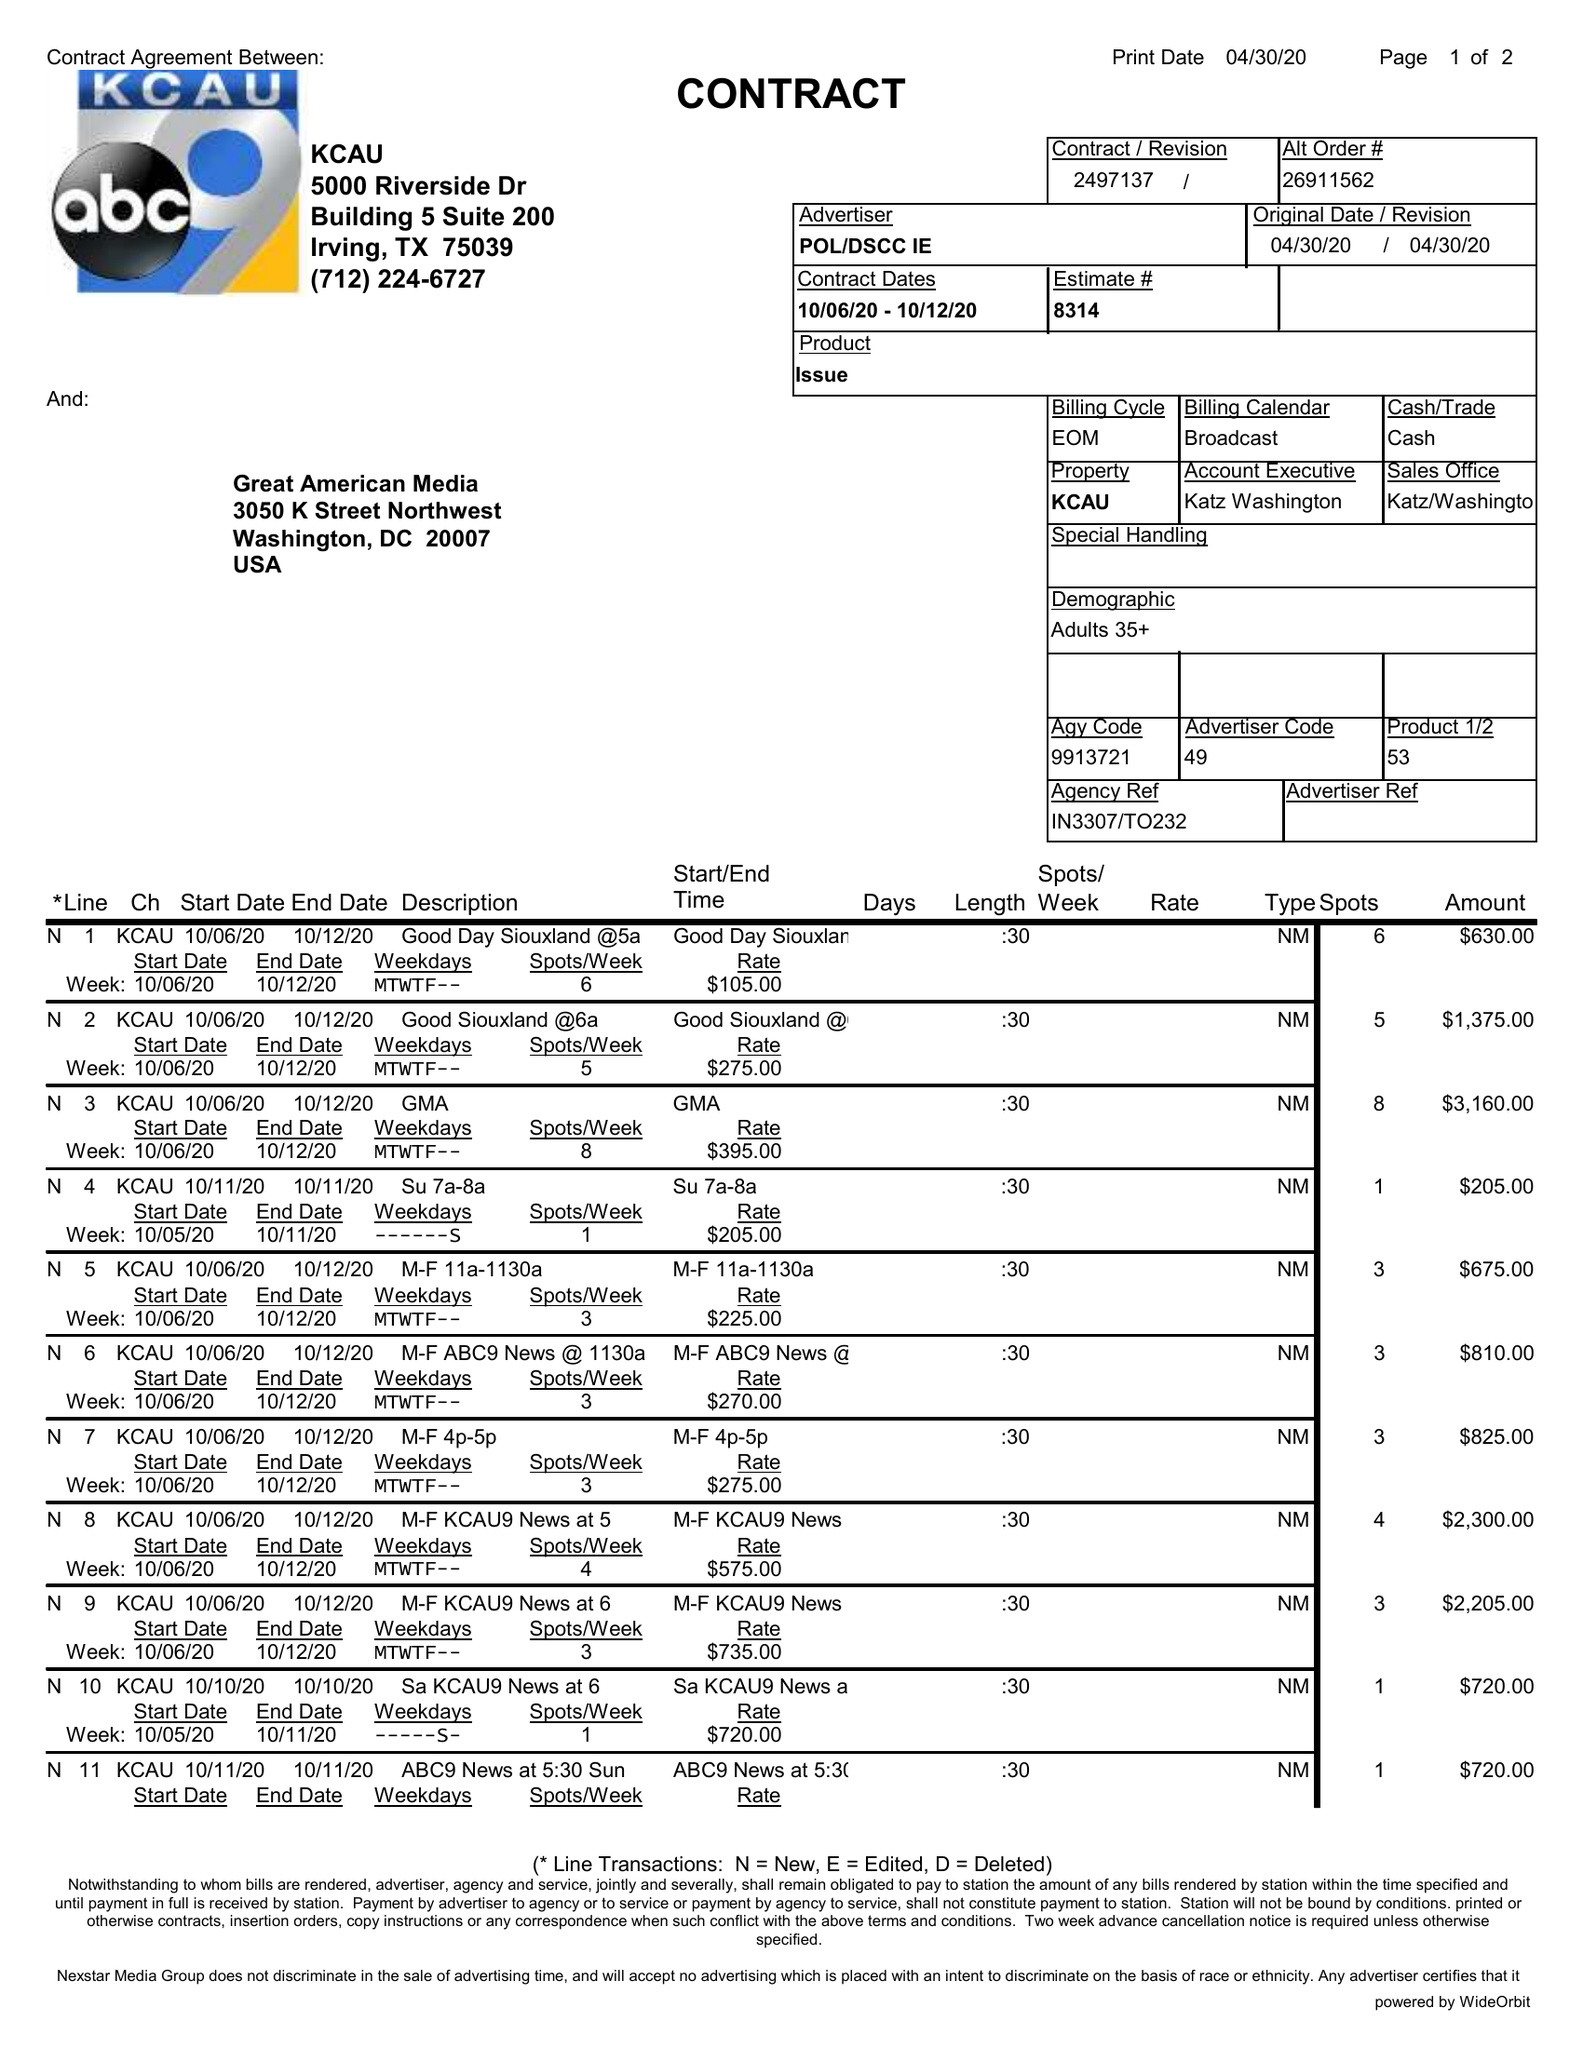What is the value for the advertiser?
Answer the question using a single word or phrase. POL/DSCCIE 